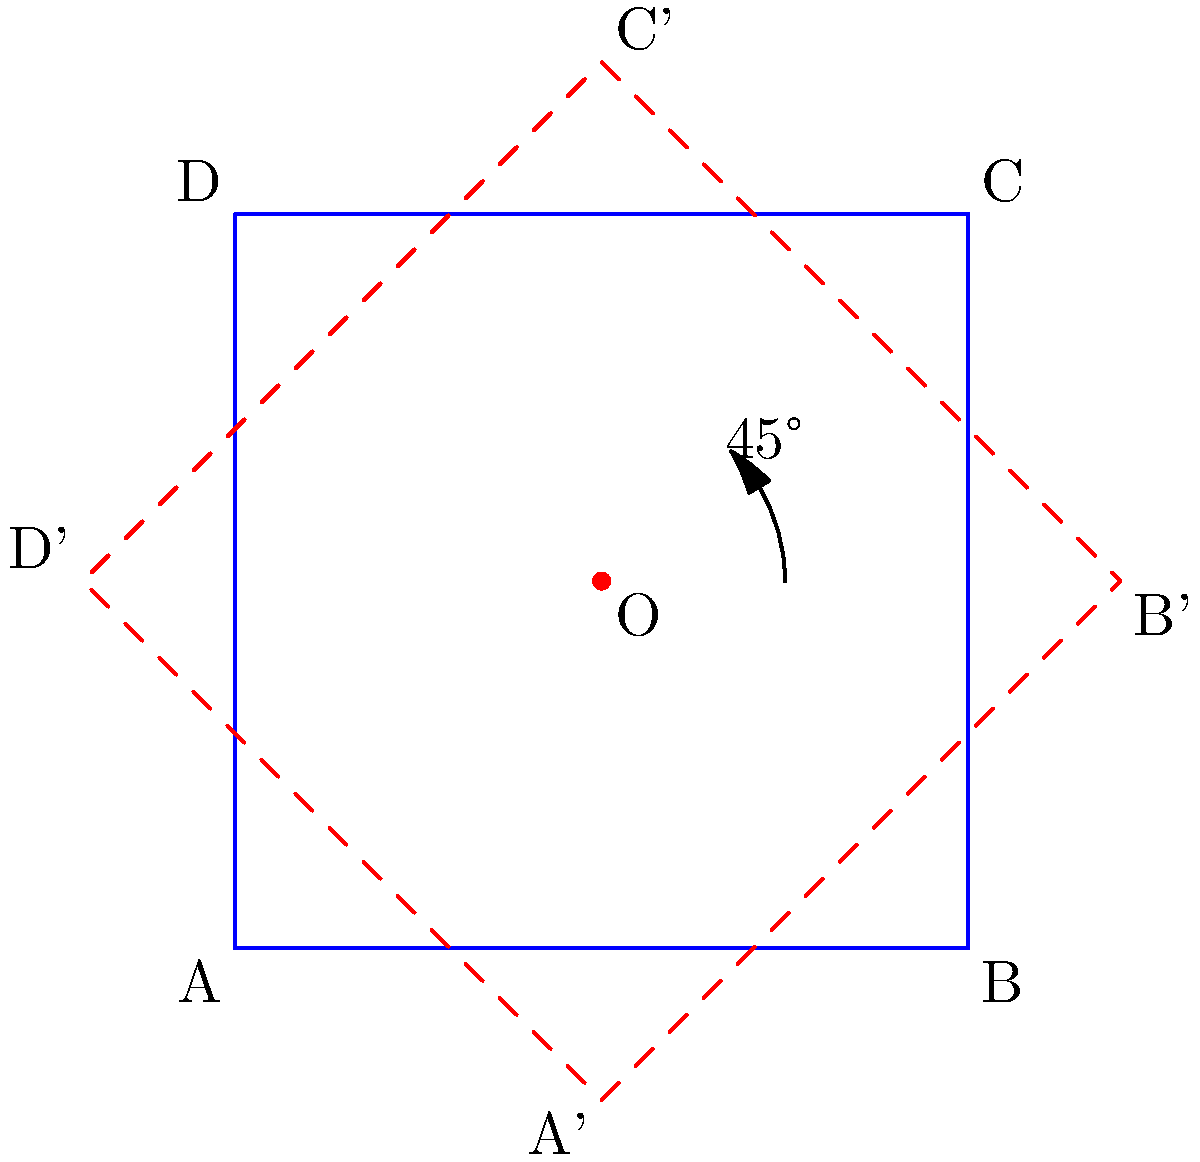A square ABCD with side length 2 units is rotated 45° counterclockwise around point O(1,1). Given that A(0,0) is rotated to A'(-0.41, 0.41), calculate the coordinates of C' (the rotated position of C) to two decimal places. To solve this problem, we'll use the rotation matrix and the properties of rotation transformations:

1) The rotation matrix for a counterclockwise rotation by θ degrees is:
   $$R = \begin{pmatrix} \cos θ & -\sin θ \\ \sin θ & \cos θ \end{pmatrix}$$

2) For a 45° rotation, $\cos 45° = \sin 45° = \frac{1}{\sqrt{2}} \approx 0.7071$

3) The rotation formula around a point (x₀, y₀) is:
   $$(x', y') = (x₀, y₀) + R((x, y) - (x₀, y₀))$$

4) We know that O(1,1) is the center of rotation and C(2,2) is the point to be rotated.

5) Let's apply the formula:
   $$(x', y') = (1, 1) + \begin{pmatrix} 0.7071 & -0.7071 \\ 0.7071 & 0.7071 \end{pmatrix} \begin{pmatrix} 2-1 \\ 2-1 \end{pmatrix}$$

6) Simplifying:
   $$(x', y') = (1, 1) + \begin{pmatrix} 0.7071 & -0.7071 \\ 0.7071 & 0.7071 \end{pmatrix} \begin{pmatrix} 1 \\ 1 \end{pmatrix}$$

7) Calculating:
   $$(x', y') = (1, 1) + \begin{pmatrix} 0 \\ 1.4142 \end{pmatrix}$$

8) Final result:
   $$(x', y') = (1, 2.4142)$$

9) Rounding to two decimal places:
   C' ≈ (1.00, 2.41)
Answer: (1.00, 2.41) 